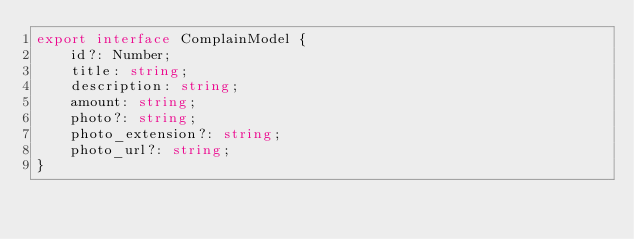Convert code to text. <code><loc_0><loc_0><loc_500><loc_500><_TypeScript_>export interface ComplainModel {
    id?: Number;
    title: string;
    description: string;
    amount: string;
    photo?: string;
    photo_extension?: string;
    photo_url?: string;
}</code> 